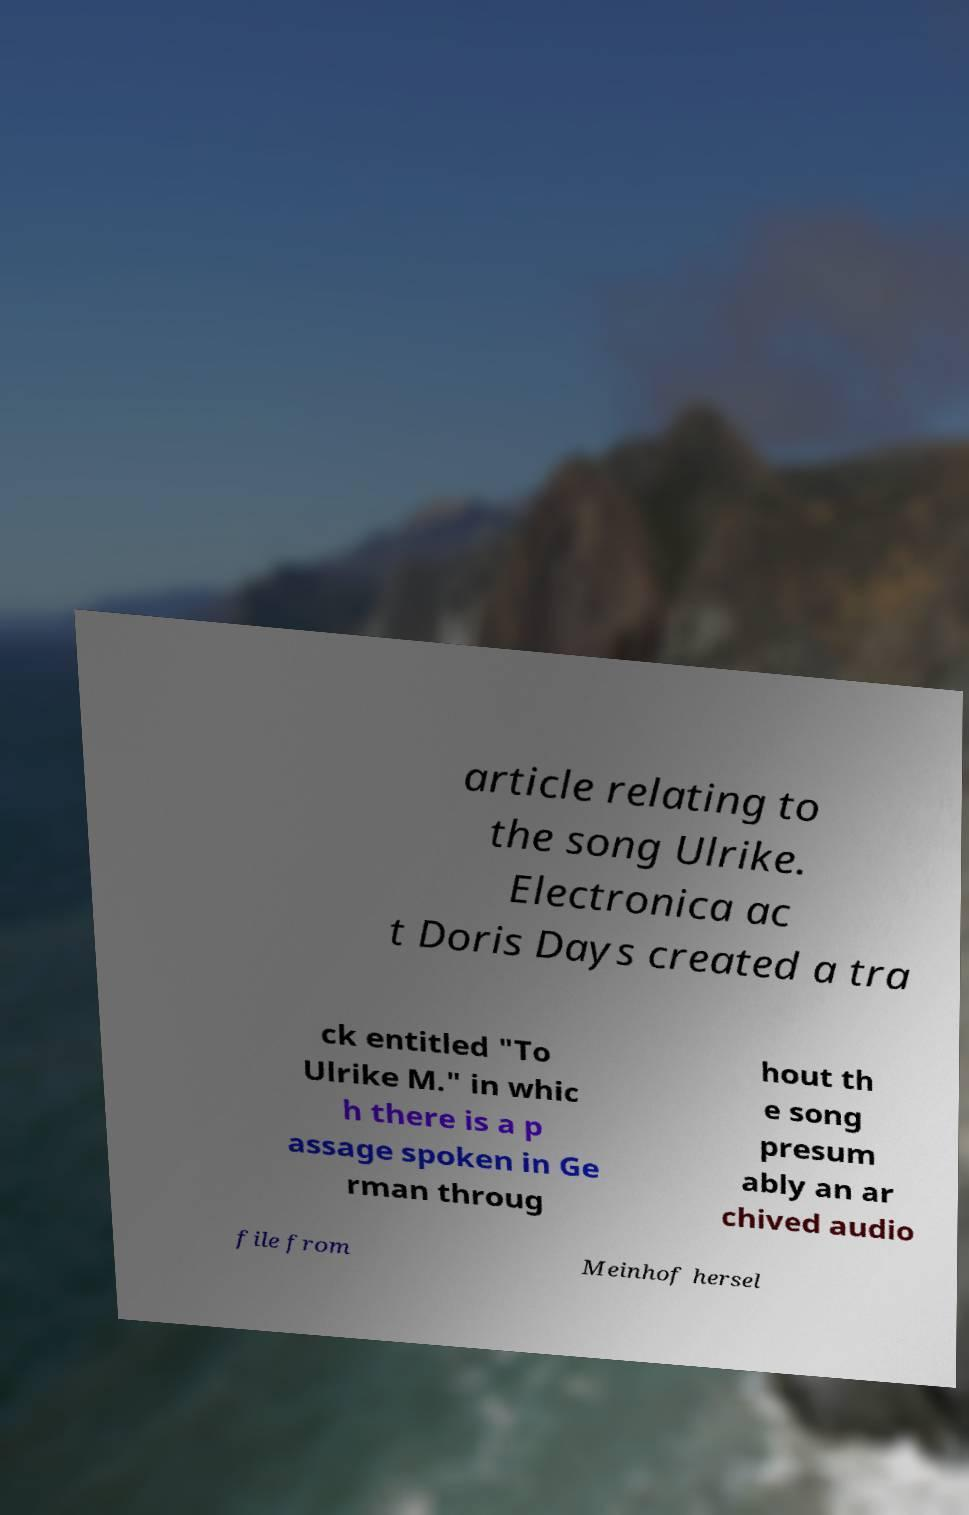What messages or text are displayed in this image? I need them in a readable, typed format. article relating to the song Ulrike. Electronica ac t Doris Days created a tra ck entitled "To Ulrike M." in whic h there is a p assage spoken in Ge rman throug hout th e song presum ably an ar chived audio file from Meinhof hersel 